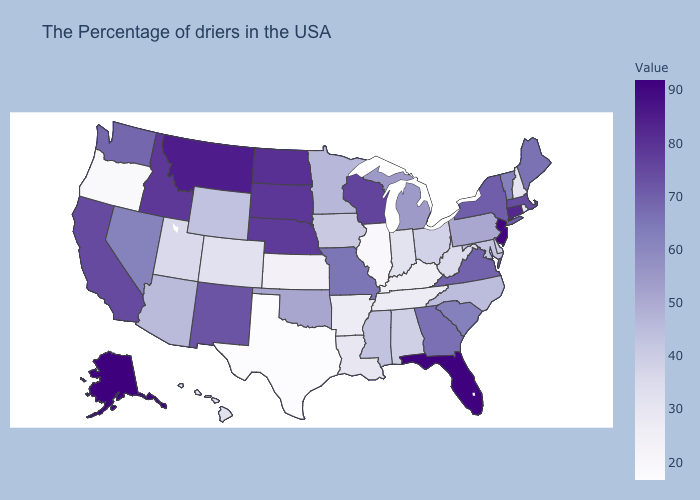Among the states that border Massachusetts , does Rhode Island have the lowest value?
Write a very short answer. Yes. Among the states that border Idaho , does Oregon have the lowest value?
Be succinct. Yes. Which states hav the highest value in the South?
Answer briefly. Florida. Does Alaska have the highest value in the USA?
Be succinct. Yes. Does North Dakota have the highest value in the MidWest?
Answer briefly. Yes. Which states hav the highest value in the MidWest?
Write a very short answer. North Dakota. Among the states that border Florida , does Georgia have the lowest value?
Give a very brief answer. No. 